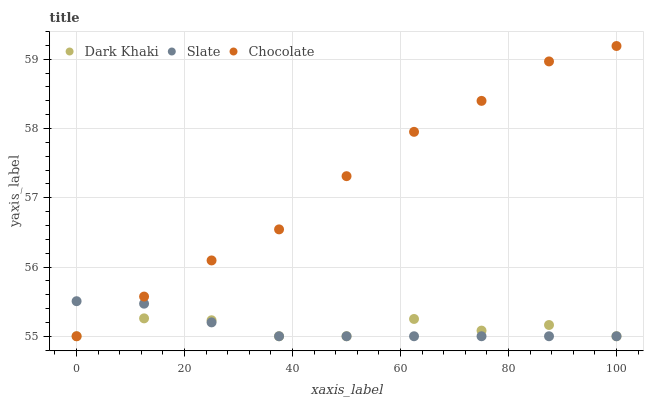Does Slate have the minimum area under the curve?
Answer yes or no. Yes. Does Chocolate have the maximum area under the curve?
Answer yes or no. Yes. Does Chocolate have the minimum area under the curve?
Answer yes or no. No. Does Slate have the maximum area under the curve?
Answer yes or no. No. Is Slate the smoothest?
Answer yes or no. Yes. Is Dark Khaki the roughest?
Answer yes or no. Yes. Is Chocolate the smoothest?
Answer yes or no. No. Is Chocolate the roughest?
Answer yes or no. No. Does Dark Khaki have the lowest value?
Answer yes or no. Yes. Does Chocolate have the highest value?
Answer yes or no. Yes. Does Slate have the highest value?
Answer yes or no. No. Does Dark Khaki intersect Chocolate?
Answer yes or no. Yes. Is Dark Khaki less than Chocolate?
Answer yes or no. No. Is Dark Khaki greater than Chocolate?
Answer yes or no. No. 